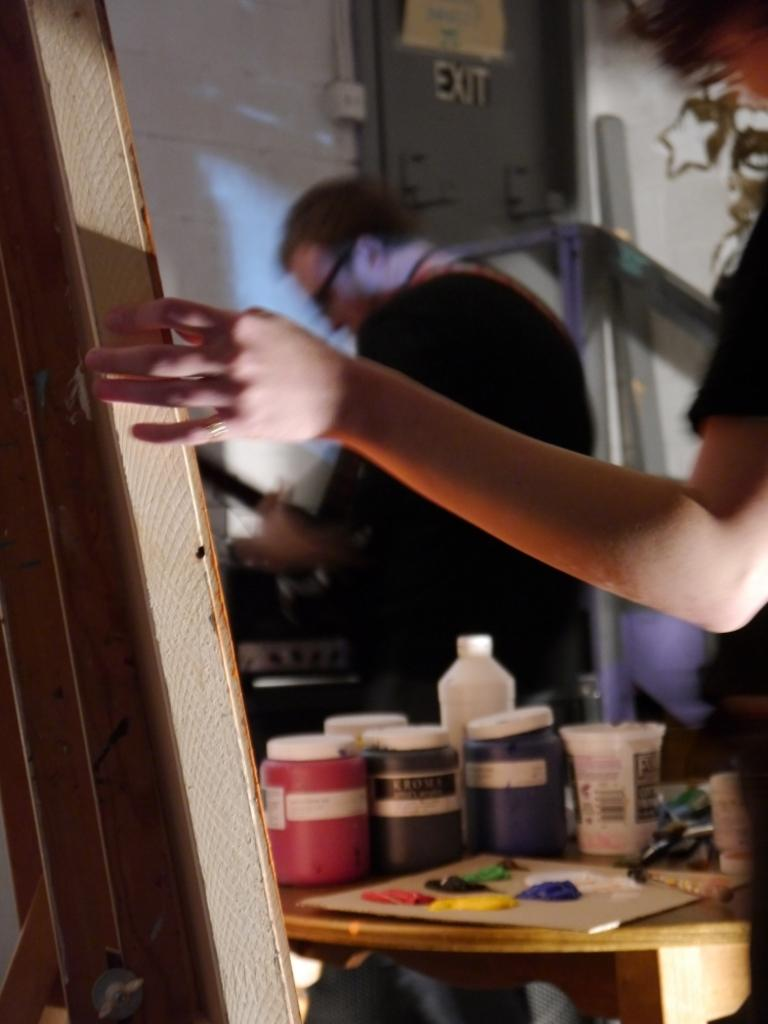What is the color of the wall in the image? The wall in the image is white. How many people are in the image? There are two people in the image. What is on the table in the image? There is a board, a color (possibly a paint or marker), a glass, a bottle, and boxes on the table. What is the purpose of the board on the table? The purpose of the board on the table is not clear from the image, but it could be used for writing or drawing. What is the color or material of the boxes on the table? The color or material of the boxes on the table is not clear from the image. Can you tell me how many plants are on the table in the image? There are no plants visible on the table in the image. What type of yak is sitting next to the people in the image? There are no yaks present in the image; only two people are visible. 